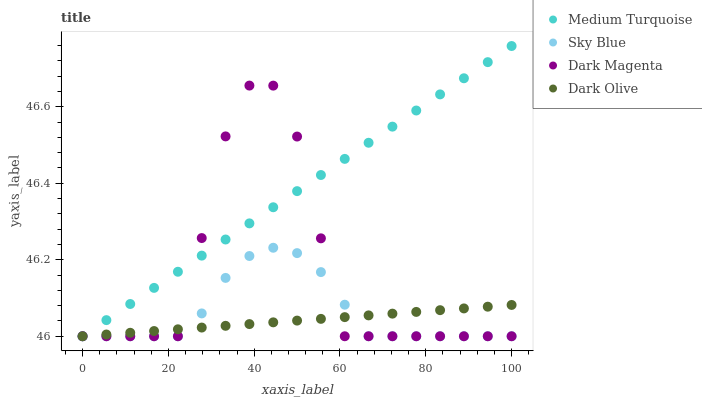Does Dark Olive have the minimum area under the curve?
Answer yes or no. Yes. Does Medium Turquoise have the maximum area under the curve?
Answer yes or no. Yes. Does Dark Magenta have the minimum area under the curve?
Answer yes or no. No. Does Dark Magenta have the maximum area under the curve?
Answer yes or no. No. Is Medium Turquoise the smoothest?
Answer yes or no. Yes. Is Dark Magenta the roughest?
Answer yes or no. Yes. Is Dark Olive the smoothest?
Answer yes or no. No. Is Dark Olive the roughest?
Answer yes or no. No. Does Sky Blue have the lowest value?
Answer yes or no. Yes. Does Medium Turquoise have the highest value?
Answer yes or no. Yes. Does Dark Magenta have the highest value?
Answer yes or no. No. Does Dark Magenta intersect Dark Olive?
Answer yes or no. Yes. Is Dark Magenta less than Dark Olive?
Answer yes or no. No. Is Dark Magenta greater than Dark Olive?
Answer yes or no. No. 